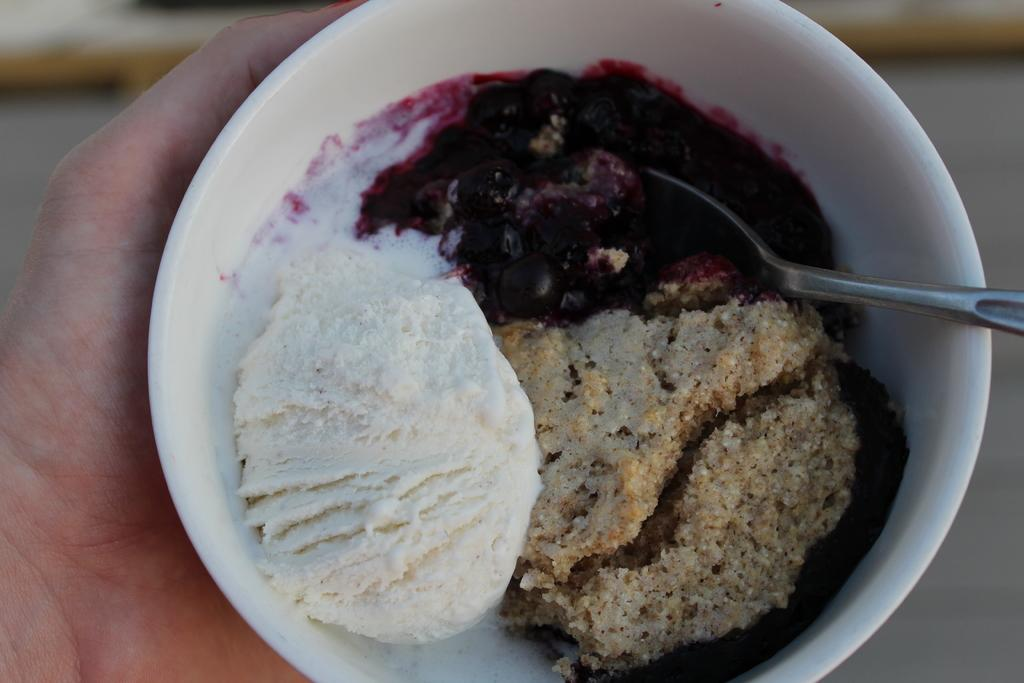What part of a person's body is visible in the image? There is a person's hand in the image. What is the hand holding? The hand is holding a bowl. What can be found inside the bowl? There are food items in the bowl. What utensil is present in the bowl? There is a spoon in the bowl. How would you describe the background of the image? The background of the image is blurred. What type of bikes are visible in the image? There are no bikes present in the image. What day of the week is it in the image? The image does not provide any information about the day of the week. 